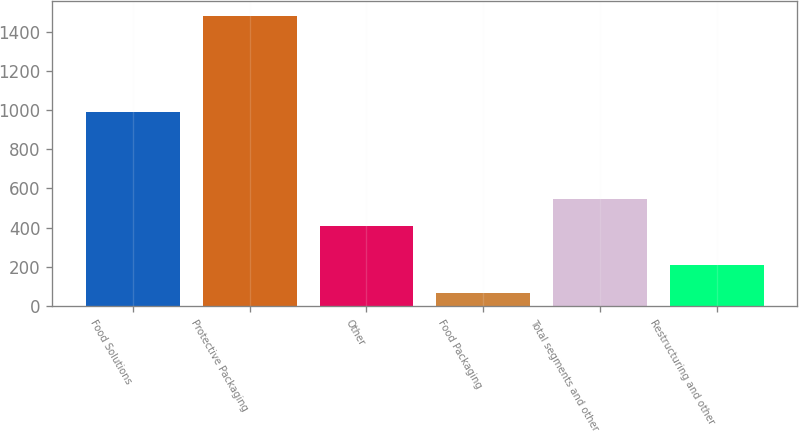Convert chart. <chart><loc_0><loc_0><loc_500><loc_500><bar_chart><fcel>Food Solutions<fcel>Protective Packaging<fcel>Other<fcel>Food Packaging<fcel>Total segments and other<fcel>Restructuring and other<nl><fcel>988.3<fcel>1480.3<fcel>405.5<fcel>67<fcel>546.83<fcel>208.33<nl></chart> 